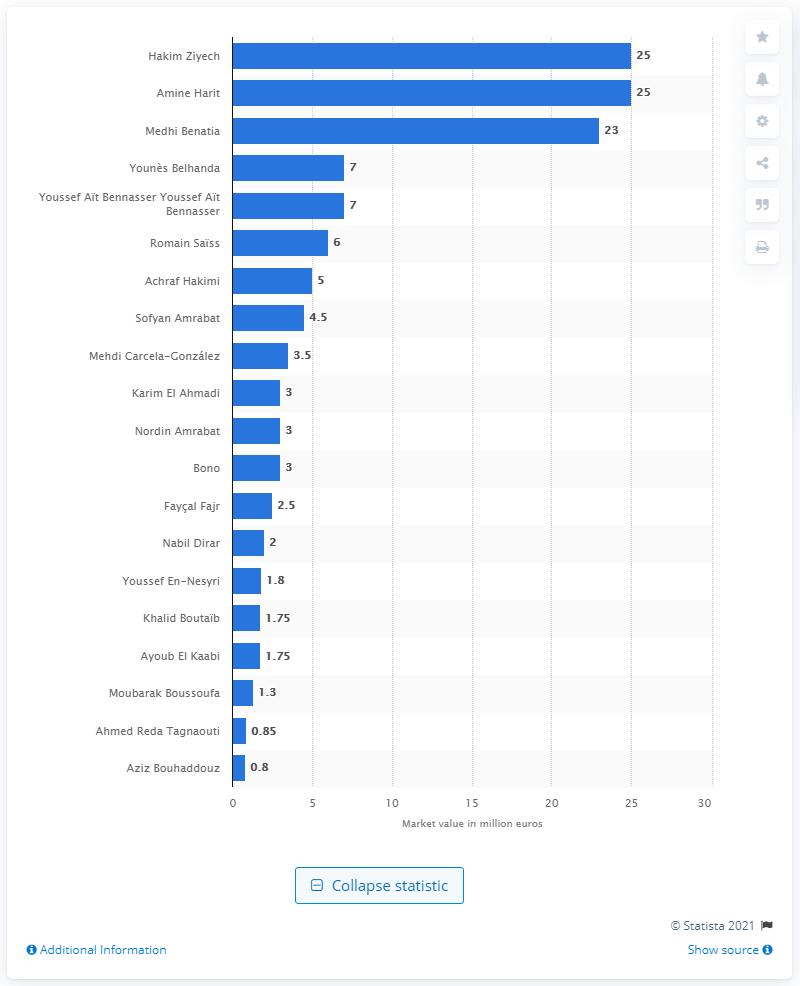Outline some significant characteristics in this image. The market value of Hakim Ziyech and Amine Harit was 25 million dollars. 